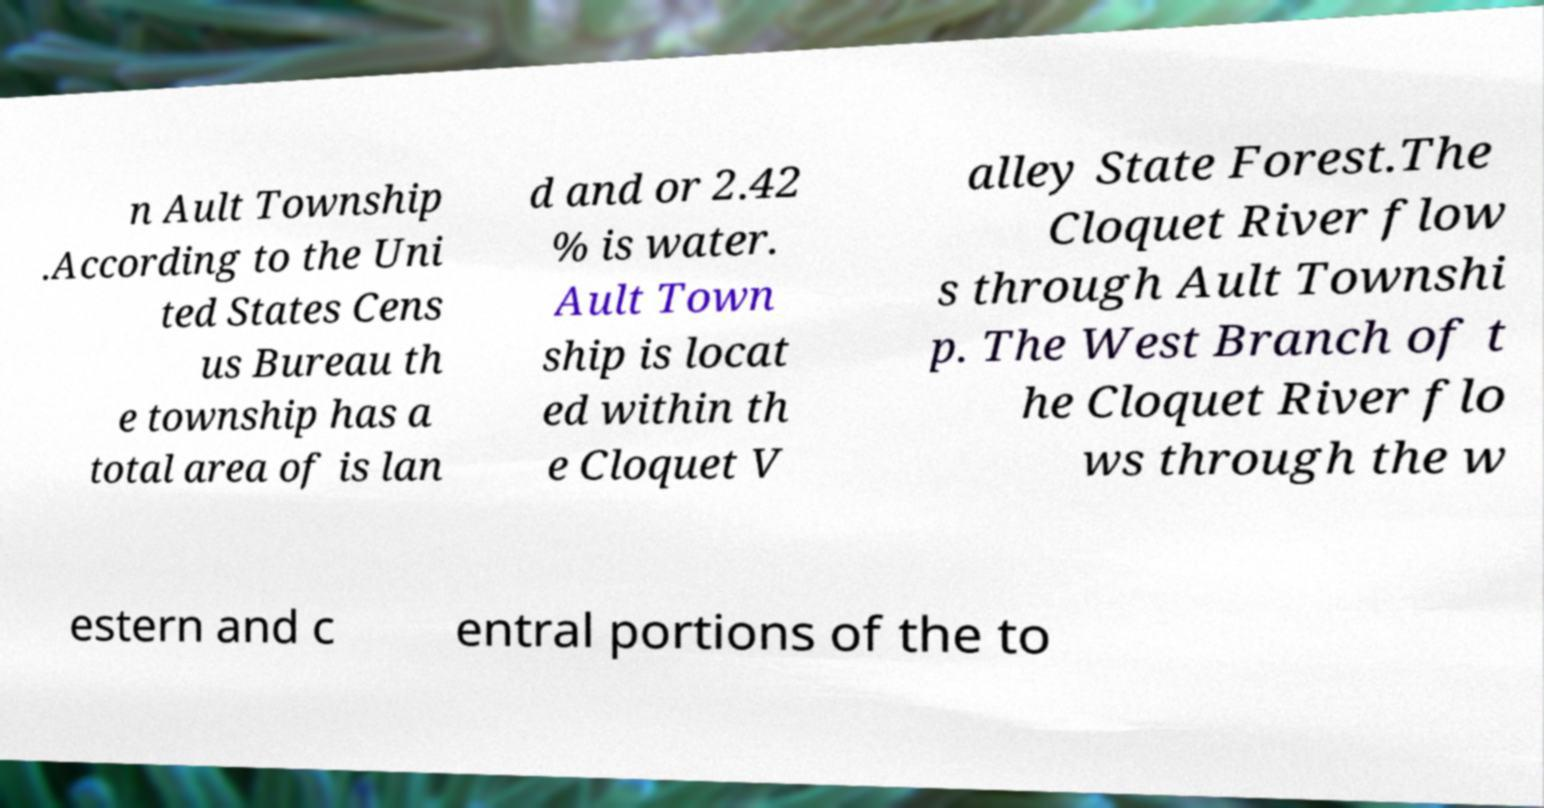Could you extract and type out the text from this image? n Ault Township .According to the Uni ted States Cens us Bureau th e township has a total area of is lan d and or 2.42 % is water. Ault Town ship is locat ed within th e Cloquet V alley State Forest.The Cloquet River flow s through Ault Townshi p. The West Branch of t he Cloquet River flo ws through the w estern and c entral portions of the to 